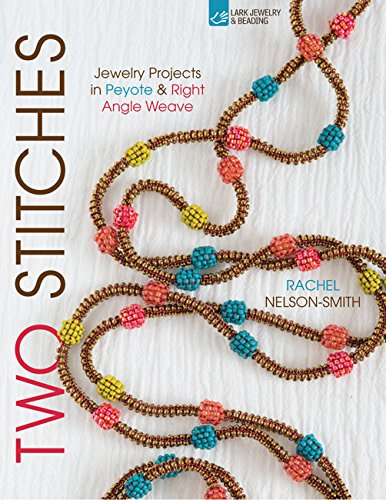Can you tell me more about the beadwork techniques featured in this book? Certainly! The book explores peyote and right angle weave techniques, which are popular in creating dimensional and textured beadwork jewelry. 